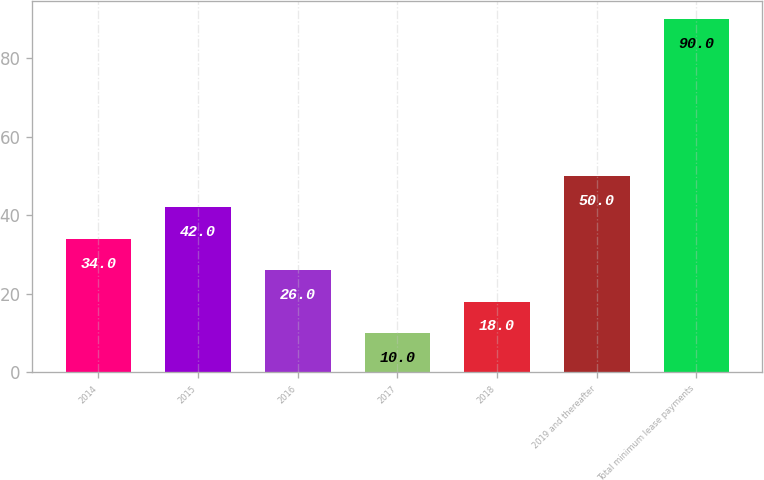<chart> <loc_0><loc_0><loc_500><loc_500><bar_chart><fcel>2014<fcel>2015<fcel>2016<fcel>2017<fcel>2018<fcel>2019 and thereafter<fcel>Total minimum lease payments<nl><fcel>34<fcel>42<fcel>26<fcel>10<fcel>18<fcel>50<fcel>90<nl></chart> 